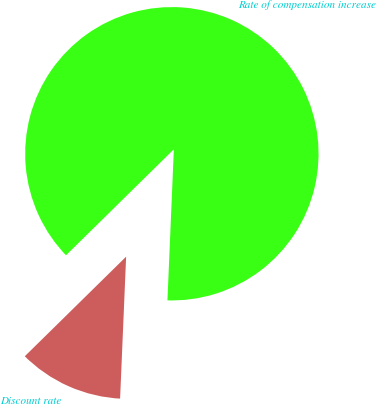Convert chart to OTSL. <chart><loc_0><loc_0><loc_500><loc_500><pie_chart><fcel>Discount rate<fcel>Rate of compensation increase<nl><fcel>11.96%<fcel>88.04%<nl></chart> 